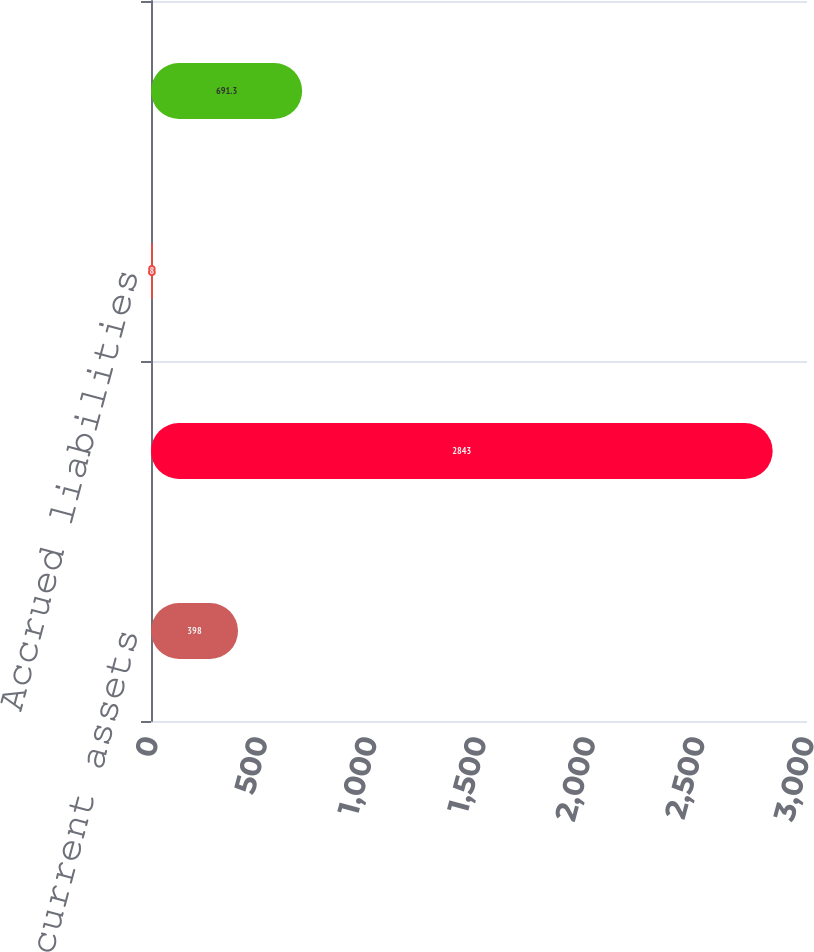<chart> <loc_0><loc_0><loc_500><loc_500><bar_chart><fcel>Other current assets<fcel>Deferred income taxes<fcel>Accrued liabilities<fcel>Net deferred tax assets<nl><fcel>398<fcel>2843<fcel>8<fcel>691.3<nl></chart> 